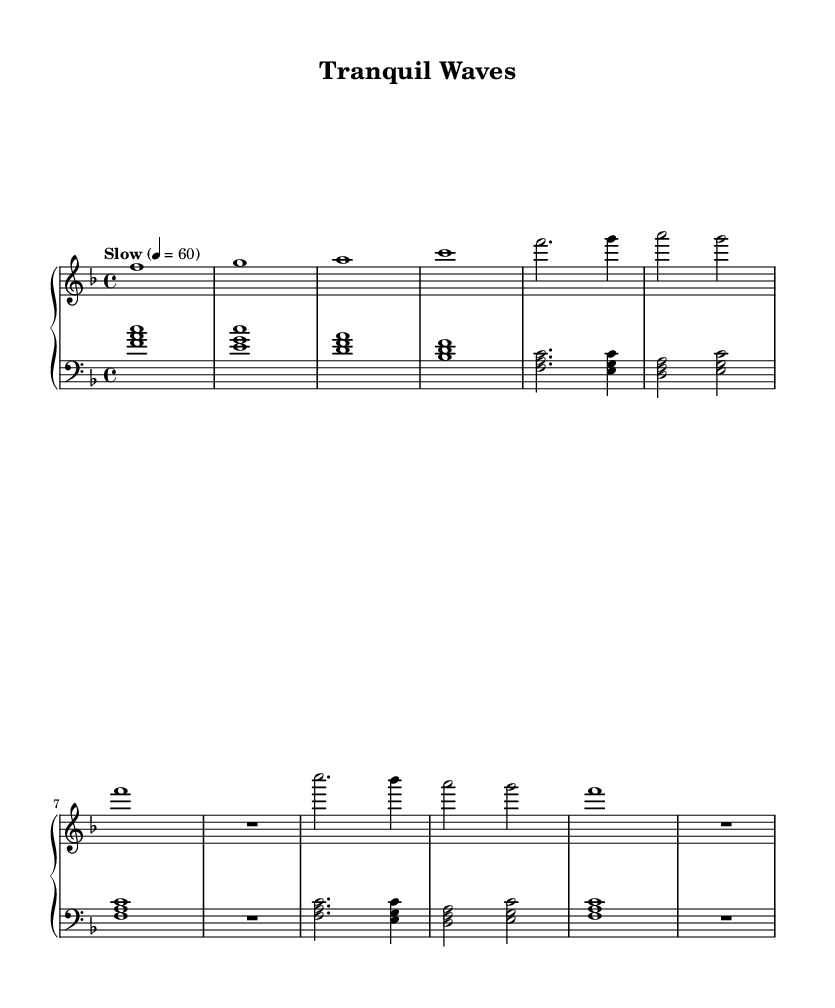What is the key signature of this music? The key signature indicates F major, which has one flat, B flat. This is derived from the global section where it specifies `\key f \major`.
Answer: F major What is the time signature of this music? The time signature shown in the global section is 4/4, which indicates four beats per measure. This is found in the `\time 4/4` line of the code.
Answer: 4/4 What is the tempo marking of this music? The tempo marking is indicated as "Slow" and specifies a speed of 60 beats per minute, found in the `\tempo "Slow" 4 = 60` line.
Answer: Slow, 60 How many measures are there in the music? By counting each segment separated by bar lines in the provided music, there are 8 measures total (4 from the intro + 4 from the main themes).
Answer: 8 measures What is the highest note played in this music? The highest note indicated in the right hand melody is C in the octave indicated by the clef, specifically in the measure where it first appears.
Answer: C Which section enjoys a rest in the melody? In both the Main Theme A and Main Theme B sections, there is a rest indicated by R1 after the main notes, signifying a pause in the melody.
Answer: Main Theme A, Main Theme B What type of chords are used in the left hand during the intro? The left hand plays triadic chords, specifically, the chords are built on the first, third, and fifth notes of each indicated key, which indicates harmony based on triads.
Answer: Triadic chords 